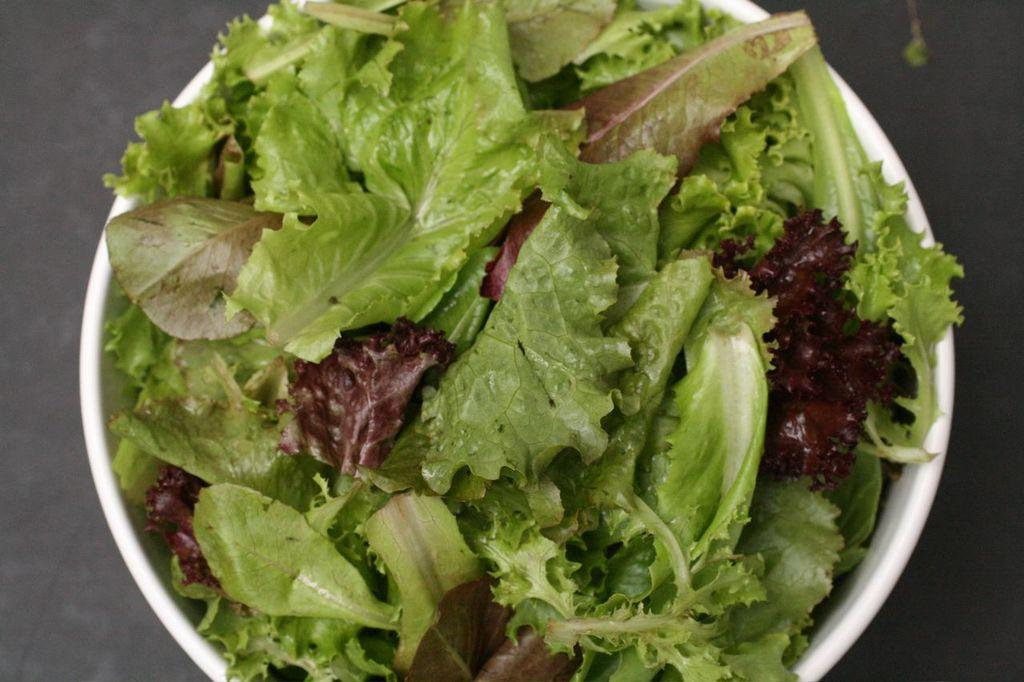What is in the bowl that is visible in the image? There are leaves in a white color bowl. Where is the bowl located in the image? The bowl is on the floor. What color is the background of the image? The background of the image is gray in color. What type of salt can be seen in the image? There is no salt present in the image; it features a bowl of white leaves on the floor with a gray background. 